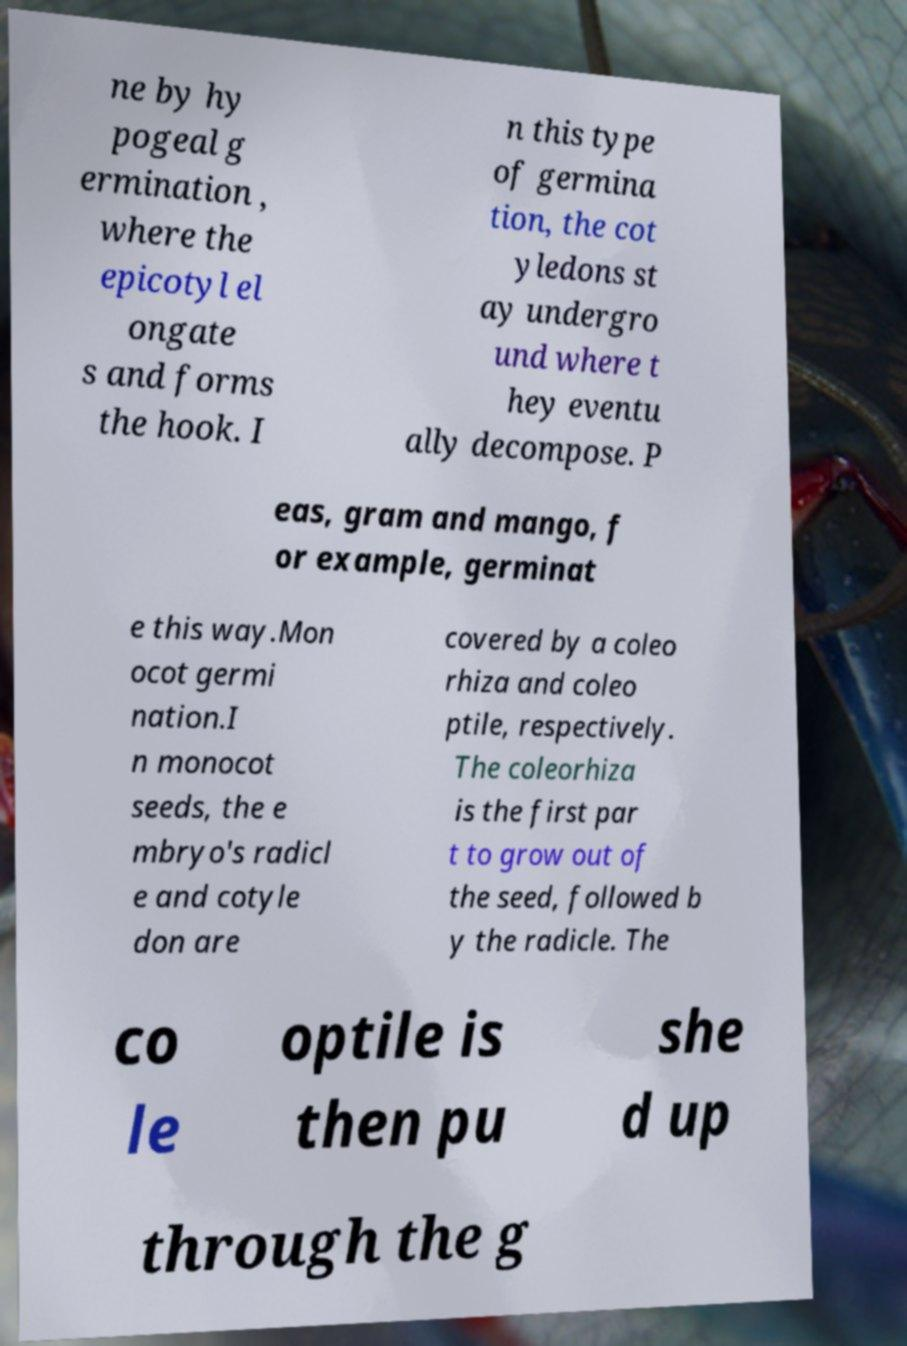For documentation purposes, I need the text within this image transcribed. Could you provide that? ne by hy pogeal g ermination , where the epicotyl el ongate s and forms the hook. I n this type of germina tion, the cot yledons st ay undergro und where t hey eventu ally decompose. P eas, gram and mango, f or example, germinat e this way.Mon ocot germi nation.I n monocot seeds, the e mbryo's radicl e and cotyle don are covered by a coleo rhiza and coleo ptile, respectively. The coleorhiza is the first par t to grow out of the seed, followed b y the radicle. The co le optile is then pu she d up through the g 